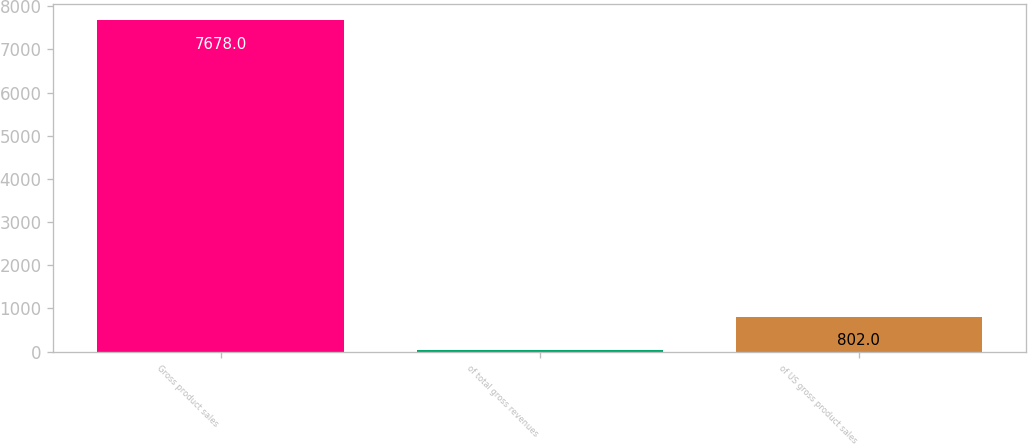Convert chart to OTSL. <chart><loc_0><loc_0><loc_500><loc_500><bar_chart><fcel>Gross product sales<fcel>of total gross revenues<fcel>of US gross product sales<nl><fcel>7678<fcel>38<fcel>802<nl></chart> 